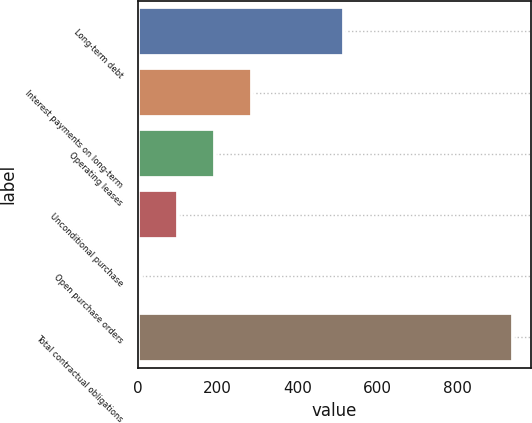<chart> <loc_0><loc_0><loc_500><loc_500><bar_chart><fcel>Long-term debt<fcel>Interest payments on long-term<fcel>Operating leases<fcel>Unconditional purchase<fcel>Open purchase orders<fcel>Total contractual obligations<nl><fcel>516<fcel>286.7<fcel>193.8<fcel>100.9<fcel>8<fcel>937<nl></chart> 